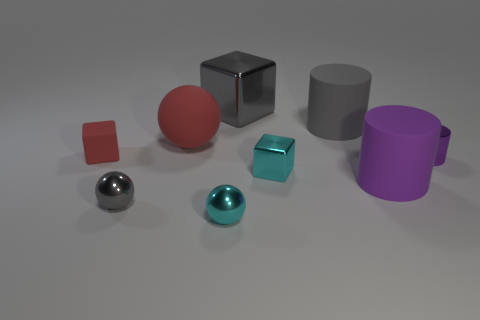What is the color of the rubber thing that is both on the right side of the big metal cube and in front of the big red matte sphere?
Your answer should be very brief. Purple. What is the small cyan object behind the purple object that is to the left of the tiny purple shiny cylinder made of?
Your answer should be compact. Metal. Does the cyan ball have the same size as the gray shiny block?
Your answer should be very brief. No. How many big objects are either cyan metallic things or red rubber cubes?
Offer a very short reply. 0. What number of tiny red things are on the right side of the red rubber ball?
Provide a short and direct response. 0. Is the number of large red things on the left side of the tiny red matte block greater than the number of large metallic things?
Keep it short and to the point. No. There is a small object that is made of the same material as the big red sphere; what shape is it?
Your response must be concise. Cube. What color is the large matte cylinder behind the tiny cube in front of the tiny purple cylinder?
Give a very brief answer. Gray. Is the shape of the big gray rubber thing the same as the big red thing?
Your response must be concise. No. What material is the cyan thing that is the same shape as the small gray object?
Your answer should be very brief. Metal. 